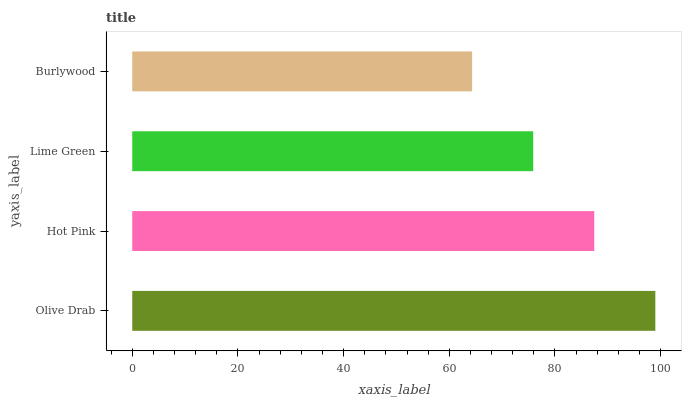Is Burlywood the minimum?
Answer yes or no. Yes. Is Olive Drab the maximum?
Answer yes or no. Yes. Is Hot Pink the minimum?
Answer yes or no. No. Is Hot Pink the maximum?
Answer yes or no. No. Is Olive Drab greater than Hot Pink?
Answer yes or no. Yes. Is Hot Pink less than Olive Drab?
Answer yes or no. Yes. Is Hot Pink greater than Olive Drab?
Answer yes or no. No. Is Olive Drab less than Hot Pink?
Answer yes or no. No. Is Hot Pink the high median?
Answer yes or no. Yes. Is Lime Green the low median?
Answer yes or no. Yes. Is Olive Drab the high median?
Answer yes or no. No. Is Olive Drab the low median?
Answer yes or no. No. 